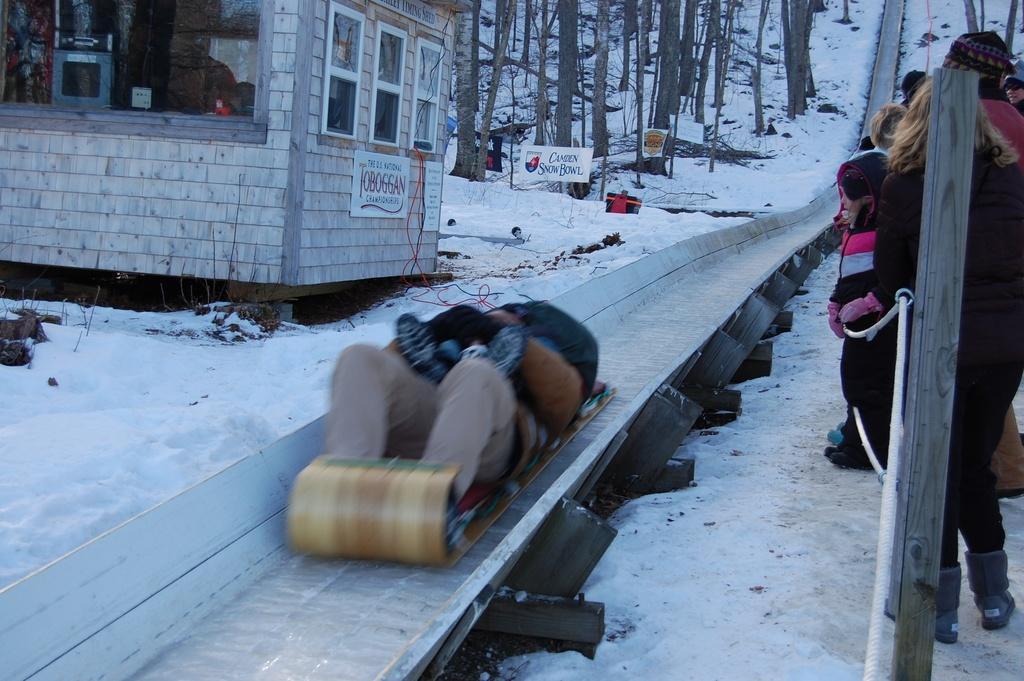Please provide a concise description of this image. In this image background is filled with a snow. Few people are standing in a group and watch sliding person. A person is sliding in the image. 